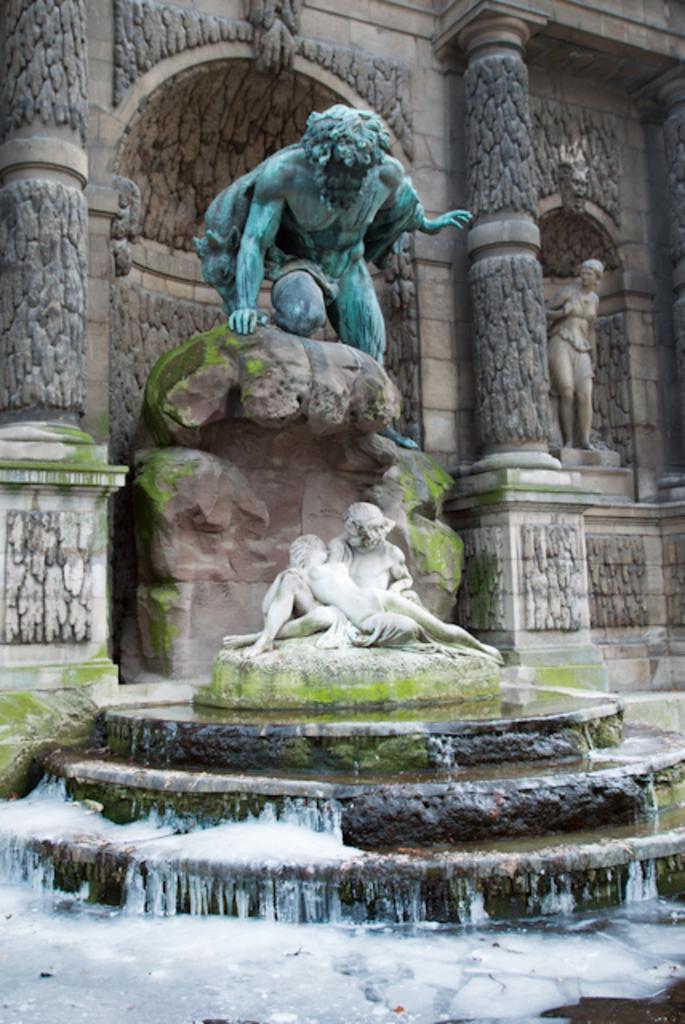Could you give a brief overview of what you see in this image? In the image there is a statue of a man above and below there is a water fall with a statue above it, in the back there is a wall with pillars and designs over it. 